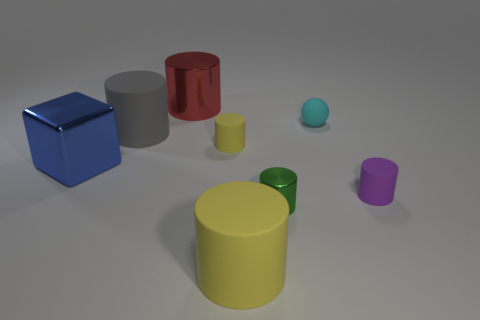What color is the large thing that is behind the blue thing and to the left of the red shiny thing?
Your response must be concise. Gray. What number of tiny brown metallic blocks are there?
Your response must be concise. 0. Do the large blue thing and the tiny sphere have the same material?
Ensure brevity in your answer.  No. What shape is the large metal object behind the small rubber object that is behind the tiny cylinder that is to the left of the green shiny thing?
Make the answer very short. Cylinder. Are the yellow cylinder that is in front of the tiny green metallic thing and the yellow cylinder that is to the left of the large yellow thing made of the same material?
Provide a succinct answer. Yes. What is the material of the green cylinder?
Give a very brief answer. Metal. How many other small cyan matte objects are the same shape as the cyan thing?
Keep it short and to the point. 0. Are there any other things that are the same shape as the blue shiny thing?
Offer a very short reply. No. What is the color of the tiny matte cylinder that is behind the big metallic thing in front of the small matte object that is to the left of the rubber sphere?
Your response must be concise. Yellow. How many small things are either blue things or matte things?
Offer a very short reply. 3. 